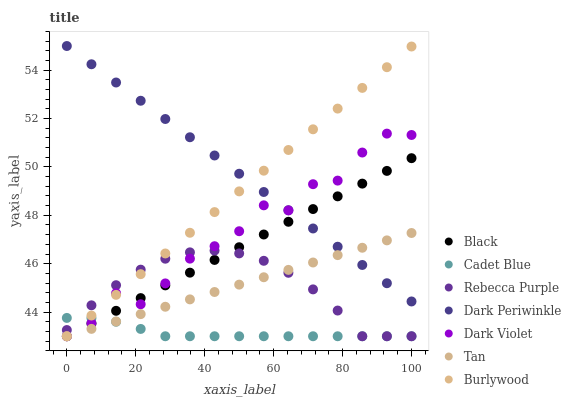Does Cadet Blue have the minimum area under the curve?
Answer yes or no. Yes. Does Dark Periwinkle have the maximum area under the curve?
Answer yes or no. Yes. Does Burlywood have the minimum area under the curve?
Answer yes or no. No. Does Burlywood have the maximum area under the curve?
Answer yes or no. No. Is Dark Periwinkle the smoothest?
Answer yes or no. Yes. Is Dark Violet the roughest?
Answer yes or no. Yes. Is Burlywood the smoothest?
Answer yes or no. No. Is Burlywood the roughest?
Answer yes or no. No. Does Cadet Blue have the lowest value?
Answer yes or no. Yes. Does Dark Periwinkle have the lowest value?
Answer yes or no. No. Does Dark Periwinkle have the highest value?
Answer yes or no. Yes. Does Burlywood have the highest value?
Answer yes or no. No. Is Cadet Blue less than Dark Periwinkle?
Answer yes or no. Yes. Is Dark Periwinkle greater than Cadet Blue?
Answer yes or no. Yes. Does Burlywood intersect Black?
Answer yes or no. Yes. Is Burlywood less than Black?
Answer yes or no. No. Is Burlywood greater than Black?
Answer yes or no. No. Does Cadet Blue intersect Dark Periwinkle?
Answer yes or no. No. 